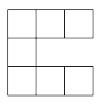How might the arrangement influence practical applications, such as tiling a floor or constructing tiled artwork? The arrangement of tiles can significantly impact both aesthetic qualities and practical usage. For floor tiling, arrangements that maximize coverage while minimizing cutting of tiles are preferred for efficiency. In artistic tiling, however, more creative and less efficient arrangements may be used to create visual interest or specific effects. Complex patterns can also influence how surfaces wear over time or how they interact with light, adding functional considerations to their design. 